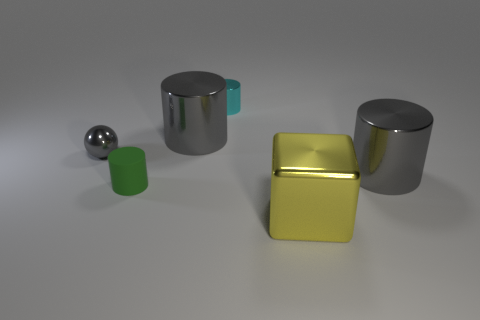Subtract 1 cylinders. How many cylinders are left? 3 Subtract all purple balls. How many gray cylinders are left? 2 Subtract all green cylinders. How many cylinders are left? 3 Subtract all matte cylinders. How many cylinders are left? 3 Add 2 red metal cubes. How many objects exist? 8 Subtract all blue cylinders. Subtract all brown blocks. How many cylinders are left? 4 Subtract all yellow metal blocks. Subtract all small objects. How many objects are left? 2 Add 3 big yellow things. How many big yellow things are left? 4 Add 6 large cyan shiny spheres. How many large cyan shiny spheres exist? 6 Subtract 1 green cylinders. How many objects are left? 5 